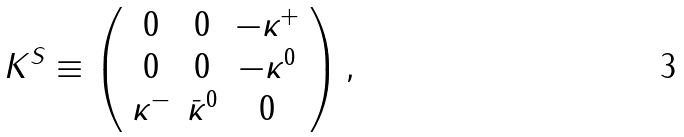Convert formula to latex. <formula><loc_0><loc_0><loc_500><loc_500>K ^ { S } \equiv \left ( \begin{array} { c c c } { 0 } & { 0 } & { { - \kappa ^ { + } } } \\ { 0 } & { 0 } & { { - \kappa ^ { 0 } } } \\ { { \kappa ^ { - } } } & { { \bar { \kappa } ^ { 0 } } } & { 0 } \end{array} \right ) ,</formula> 